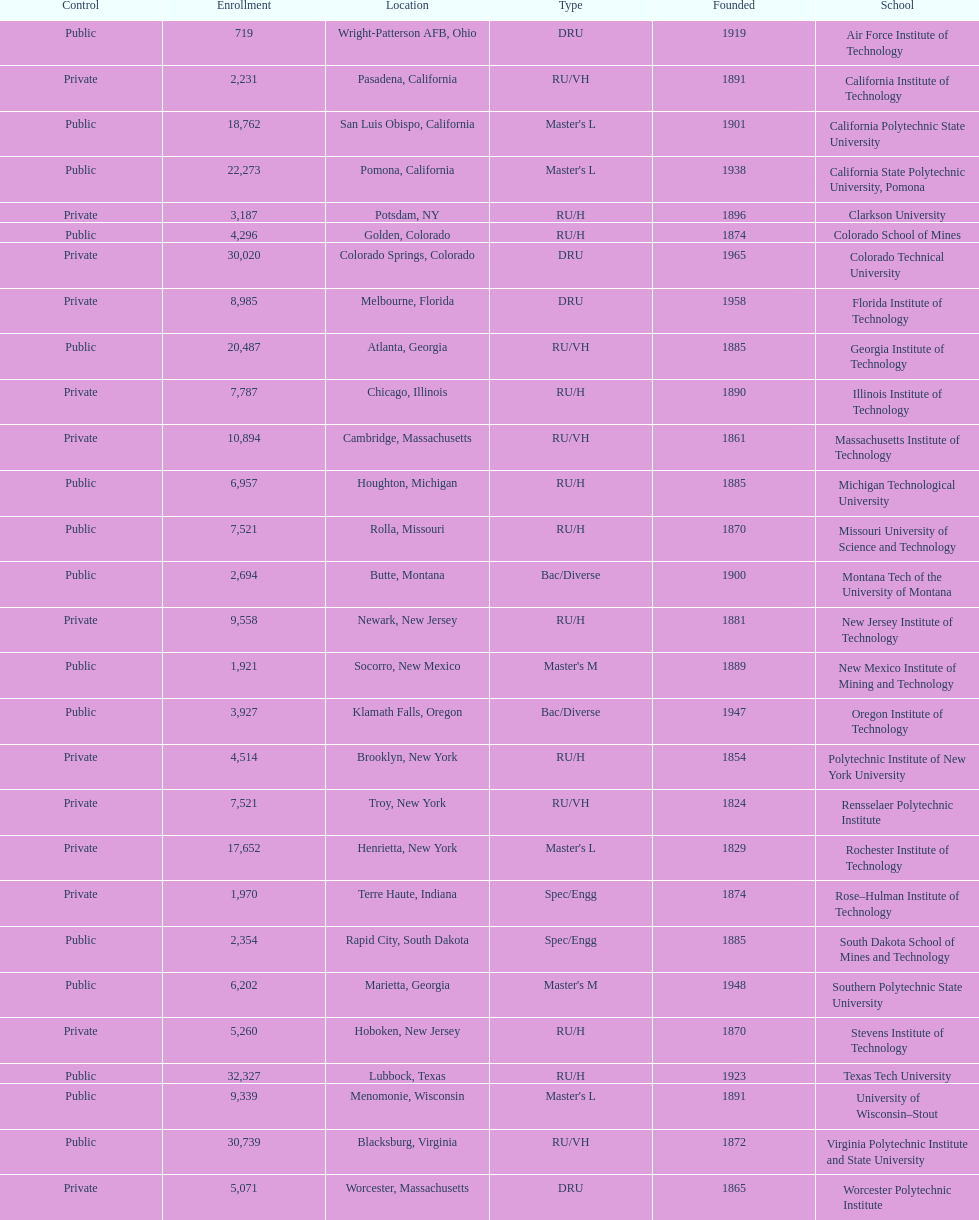What's the number of schools represented in the table? 28. 